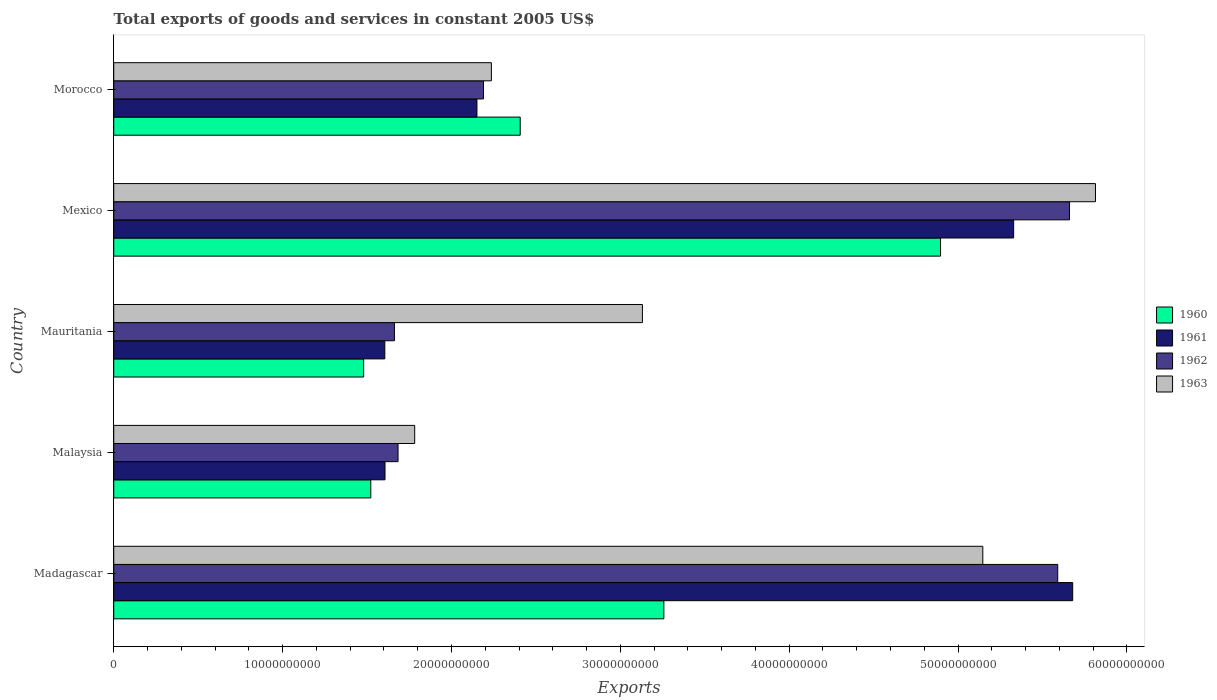How many groups of bars are there?
Provide a short and direct response. 5. Are the number of bars on each tick of the Y-axis equal?
Offer a very short reply. Yes. How many bars are there on the 5th tick from the bottom?
Provide a succinct answer. 4. What is the label of the 3rd group of bars from the top?
Offer a terse response. Mauritania. What is the total exports of goods and services in 1960 in Madagascar?
Your response must be concise. 3.26e+1. Across all countries, what is the maximum total exports of goods and services in 1962?
Your answer should be very brief. 5.66e+1. Across all countries, what is the minimum total exports of goods and services in 1963?
Provide a succinct answer. 1.78e+1. In which country was the total exports of goods and services in 1961 maximum?
Ensure brevity in your answer.  Madagascar. In which country was the total exports of goods and services in 1963 minimum?
Your response must be concise. Malaysia. What is the total total exports of goods and services in 1963 in the graph?
Keep it short and to the point. 1.81e+11. What is the difference between the total exports of goods and services in 1963 in Mexico and that in Morocco?
Give a very brief answer. 3.58e+1. What is the difference between the total exports of goods and services in 1960 in Mauritania and the total exports of goods and services in 1962 in Madagascar?
Give a very brief answer. -4.11e+1. What is the average total exports of goods and services in 1961 per country?
Offer a terse response. 3.27e+1. What is the difference between the total exports of goods and services in 1963 and total exports of goods and services in 1960 in Madagascar?
Offer a very short reply. 1.89e+1. What is the ratio of the total exports of goods and services in 1961 in Malaysia to that in Mexico?
Your response must be concise. 0.3. Is the total exports of goods and services in 1961 in Mexico less than that in Morocco?
Your response must be concise. No. What is the difference between the highest and the second highest total exports of goods and services in 1960?
Provide a succinct answer. 1.64e+1. What is the difference between the highest and the lowest total exports of goods and services in 1960?
Ensure brevity in your answer.  3.42e+1. Is it the case that in every country, the sum of the total exports of goods and services in 1960 and total exports of goods and services in 1962 is greater than the sum of total exports of goods and services in 1963 and total exports of goods and services in 1961?
Provide a short and direct response. No. What does the 1st bar from the top in Morocco represents?
Your response must be concise. 1963. How many countries are there in the graph?
Your answer should be compact. 5. How many legend labels are there?
Keep it short and to the point. 4. How are the legend labels stacked?
Your answer should be very brief. Vertical. What is the title of the graph?
Give a very brief answer. Total exports of goods and services in constant 2005 US$. Does "2007" appear as one of the legend labels in the graph?
Your answer should be compact. No. What is the label or title of the X-axis?
Keep it short and to the point. Exports. What is the Exports in 1960 in Madagascar?
Your answer should be compact. 3.26e+1. What is the Exports in 1961 in Madagascar?
Give a very brief answer. 5.68e+1. What is the Exports in 1962 in Madagascar?
Give a very brief answer. 5.59e+1. What is the Exports of 1963 in Madagascar?
Offer a very short reply. 5.15e+1. What is the Exports of 1960 in Malaysia?
Give a very brief answer. 1.52e+1. What is the Exports in 1961 in Malaysia?
Your answer should be compact. 1.61e+1. What is the Exports of 1962 in Malaysia?
Make the answer very short. 1.68e+1. What is the Exports of 1963 in Malaysia?
Make the answer very short. 1.78e+1. What is the Exports of 1960 in Mauritania?
Keep it short and to the point. 1.48e+1. What is the Exports in 1961 in Mauritania?
Offer a terse response. 1.61e+1. What is the Exports in 1962 in Mauritania?
Your answer should be compact. 1.66e+1. What is the Exports in 1963 in Mauritania?
Offer a very short reply. 3.13e+1. What is the Exports of 1960 in Mexico?
Your response must be concise. 4.90e+1. What is the Exports of 1961 in Mexico?
Ensure brevity in your answer.  5.33e+1. What is the Exports of 1962 in Mexico?
Your response must be concise. 5.66e+1. What is the Exports in 1963 in Mexico?
Keep it short and to the point. 5.81e+1. What is the Exports of 1960 in Morocco?
Provide a succinct answer. 2.41e+1. What is the Exports in 1961 in Morocco?
Your response must be concise. 2.15e+1. What is the Exports in 1962 in Morocco?
Your answer should be compact. 2.19e+1. What is the Exports of 1963 in Morocco?
Keep it short and to the point. 2.24e+1. Across all countries, what is the maximum Exports in 1960?
Your response must be concise. 4.90e+1. Across all countries, what is the maximum Exports of 1961?
Keep it short and to the point. 5.68e+1. Across all countries, what is the maximum Exports of 1962?
Provide a succinct answer. 5.66e+1. Across all countries, what is the maximum Exports in 1963?
Provide a short and direct response. 5.81e+1. Across all countries, what is the minimum Exports of 1960?
Provide a succinct answer. 1.48e+1. Across all countries, what is the minimum Exports of 1961?
Ensure brevity in your answer.  1.61e+1. Across all countries, what is the minimum Exports in 1962?
Your response must be concise. 1.66e+1. Across all countries, what is the minimum Exports in 1963?
Ensure brevity in your answer.  1.78e+1. What is the total Exports in 1960 in the graph?
Ensure brevity in your answer.  1.36e+11. What is the total Exports of 1961 in the graph?
Provide a succinct answer. 1.64e+11. What is the total Exports of 1962 in the graph?
Make the answer very short. 1.68e+11. What is the total Exports in 1963 in the graph?
Offer a very short reply. 1.81e+11. What is the difference between the Exports of 1960 in Madagascar and that in Malaysia?
Provide a succinct answer. 1.74e+1. What is the difference between the Exports in 1961 in Madagascar and that in Malaysia?
Offer a terse response. 4.07e+1. What is the difference between the Exports in 1962 in Madagascar and that in Malaysia?
Keep it short and to the point. 3.91e+1. What is the difference between the Exports of 1963 in Madagascar and that in Malaysia?
Ensure brevity in your answer.  3.36e+1. What is the difference between the Exports in 1960 in Madagascar and that in Mauritania?
Your answer should be compact. 1.78e+1. What is the difference between the Exports in 1961 in Madagascar and that in Mauritania?
Your response must be concise. 4.07e+1. What is the difference between the Exports in 1962 in Madagascar and that in Mauritania?
Your response must be concise. 3.93e+1. What is the difference between the Exports of 1963 in Madagascar and that in Mauritania?
Your response must be concise. 2.02e+1. What is the difference between the Exports of 1960 in Madagascar and that in Mexico?
Give a very brief answer. -1.64e+1. What is the difference between the Exports of 1961 in Madagascar and that in Mexico?
Your response must be concise. 3.50e+09. What is the difference between the Exports in 1962 in Madagascar and that in Mexico?
Provide a short and direct response. -6.99e+08. What is the difference between the Exports of 1963 in Madagascar and that in Mexico?
Keep it short and to the point. -6.67e+09. What is the difference between the Exports of 1960 in Madagascar and that in Morocco?
Provide a short and direct response. 8.51e+09. What is the difference between the Exports in 1961 in Madagascar and that in Morocco?
Make the answer very short. 3.53e+1. What is the difference between the Exports in 1962 in Madagascar and that in Morocco?
Your answer should be very brief. 3.40e+1. What is the difference between the Exports of 1963 in Madagascar and that in Morocco?
Offer a terse response. 2.91e+1. What is the difference between the Exports of 1960 in Malaysia and that in Mauritania?
Give a very brief answer. 4.22e+08. What is the difference between the Exports of 1961 in Malaysia and that in Mauritania?
Provide a short and direct response. 1.20e+07. What is the difference between the Exports in 1962 in Malaysia and that in Mauritania?
Ensure brevity in your answer.  2.15e+08. What is the difference between the Exports of 1963 in Malaysia and that in Mauritania?
Provide a short and direct response. -1.35e+1. What is the difference between the Exports of 1960 in Malaysia and that in Mexico?
Provide a succinct answer. -3.37e+1. What is the difference between the Exports of 1961 in Malaysia and that in Mexico?
Offer a very short reply. -3.72e+1. What is the difference between the Exports of 1962 in Malaysia and that in Mexico?
Your answer should be very brief. -3.98e+1. What is the difference between the Exports in 1963 in Malaysia and that in Mexico?
Make the answer very short. -4.03e+1. What is the difference between the Exports of 1960 in Malaysia and that in Morocco?
Ensure brevity in your answer.  -8.85e+09. What is the difference between the Exports in 1961 in Malaysia and that in Morocco?
Give a very brief answer. -5.44e+09. What is the difference between the Exports in 1962 in Malaysia and that in Morocco?
Ensure brevity in your answer.  -5.06e+09. What is the difference between the Exports of 1963 in Malaysia and that in Morocco?
Your response must be concise. -4.54e+09. What is the difference between the Exports of 1960 in Mauritania and that in Mexico?
Give a very brief answer. -3.42e+1. What is the difference between the Exports of 1961 in Mauritania and that in Mexico?
Give a very brief answer. -3.72e+1. What is the difference between the Exports in 1962 in Mauritania and that in Mexico?
Your response must be concise. -4.00e+1. What is the difference between the Exports in 1963 in Mauritania and that in Mexico?
Provide a short and direct response. -2.68e+1. What is the difference between the Exports in 1960 in Mauritania and that in Morocco?
Give a very brief answer. -9.27e+09. What is the difference between the Exports of 1961 in Mauritania and that in Morocco?
Your answer should be compact. -5.46e+09. What is the difference between the Exports in 1962 in Mauritania and that in Morocco?
Your answer should be very brief. -5.28e+09. What is the difference between the Exports in 1963 in Mauritania and that in Morocco?
Offer a terse response. 8.95e+09. What is the difference between the Exports of 1960 in Mexico and that in Morocco?
Your answer should be very brief. 2.49e+1. What is the difference between the Exports in 1961 in Mexico and that in Morocco?
Offer a very short reply. 3.18e+1. What is the difference between the Exports in 1962 in Mexico and that in Morocco?
Provide a short and direct response. 3.47e+1. What is the difference between the Exports of 1963 in Mexico and that in Morocco?
Give a very brief answer. 3.58e+1. What is the difference between the Exports of 1960 in Madagascar and the Exports of 1961 in Malaysia?
Provide a short and direct response. 1.65e+1. What is the difference between the Exports in 1960 in Madagascar and the Exports in 1962 in Malaysia?
Give a very brief answer. 1.57e+1. What is the difference between the Exports of 1960 in Madagascar and the Exports of 1963 in Malaysia?
Offer a terse response. 1.48e+1. What is the difference between the Exports in 1961 in Madagascar and the Exports in 1962 in Malaysia?
Offer a very short reply. 4.00e+1. What is the difference between the Exports of 1961 in Madagascar and the Exports of 1963 in Malaysia?
Your answer should be very brief. 3.90e+1. What is the difference between the Exports of 1962 in Madagascar and the Exports of 1963 in Malaysia?
Provide a short and direct response. 3.81e+1. What is the difference between the Exports of 1960 in Madagascar and the Exports of 1961 in Mauritania?
Keep it short and to the point. 1.65e+1. What is the difference between the Exports of 1960 in Madagascar and the Exports of 1962 in Mauritania?
Provide a succinct answer. 1.60e+1. What is the difference between the Exports in 1960 in Madagascar and the Exports in 1963 in Mauritania?
Make the answer very short. 1.27e+09. What is the difference between the Exports in 1961 in Madagascar and the Exports in 1962 in Mauritania?
Ensure brevity in your answer.  4.02e+1. What is the difference between the Exports in 1961 in Madagascar and the Exports in 1963 in Mauritania?
Make the answer very short. 2.55e+1. What is the difference between the Exports in 1962 in Madagascar and the Exports in 1963 in Mauritania?
Keep it short and to the point. 2.46e+1. What is the difference between the Exports in 1960 in Madagascar and the Exports in 1961 in Mexico?
Your response must be concise. -2.07e+1. What is the difference between the Exports of 1960 in Madagascar and the Exports of 1962 in Mexico?
Your answer should be very brief. -2.40e+1. What is the difference between the Exports in 1960 in Madagascar and the Exports in 1963 in Mexico?
Provide a succinct answer. -2.56e+1. What is the difference between the Exports of 1961 in Madagascar and the Exports of 1962 in Mexico?
Your answer should be very brief. 1.89e+08. What is the difference between the Exports of 1961 in Madagascar and the Exports of 1963 in Mexico?
Give a very brief answer. -1.35e+09. What is the difference between the Exports in 1962 in Madagascar and the Exports in 1963 in Mexico?
Your response must be concise. -2.24e+09. What is the difference between the Exports in 1960 in Madagascar and the Exports in 1961 in Morocco?
Your answer should be compact. 1.11e+1. What is the difference between the Exports of 1960 in Madagascar and the Exports of 1962 in Morocco?
Your response must be concise. 1.07e+1. What is the difference between the Exports of 1960 in Madagascar and the Exports of 1963 in Morocco?
Make the answer very short. 1.02e+1. What is the difference between the Exports in 1961 in Madagascar and the Exports in 1962 in Morocco?
Your answer should be very brief. 3.49e+1. What is the difference between the Exports in 1961 in Madagascar and the Exports in 1963 in Morocco?
Give a very brief answer. 3.44e+1. What is the difference between the Exports in 1962 in Madagascar and the Exports in 1963 in Morocco?
Offer a terse response. 3.35e+1. What is the difference between the Exports in 1960 in Malaysia and the Exports in 1961 in Mauritania?
Your answer should be very brief. -8.31e+08. What is the difference between the Exports of 1960 in Malaysia and the Exports of 1962 in Mauritania?
Provide a succinct answer. -1.40e+09. What is the difference between the Exports of 1960 in Malaysia and the Exports of 1963 in Mauritania?
Ensure brevity in your answer.  -1.61e+1. What is the difference between the Exports in 1961 in Malaysia and the Exports in 1962 in Mauritania?
Make the answer very short. -5.57e+08. What is the difference between the Exports in 1961 in Malaysia and the Exports in 1963 in Mauritania?
Offer a very short reply. -1.52e+1. What is the difference between the Exports of 1962 in Malaysia and the Exports of 1963 in Mauritania?
Ensure brevity in your answer.  -1.45e+1. What is the difference between the Exports in 1960 in Malaysia and the Exports in 1961 in Mexico?
Provide a succinct answer. -3.81e+1. What is the difference between the Exports in 1960 in Malaysia and the Exports in 1962 in Mexico?
Provide a short and direct response. -4.14e+1. What is the difference between the Exports in 1960 in Malaysia and the Exports in 1963 in Mexico?
Offer a very short reply. -4.29e+1. What is the difference between the Exports of 1961 in Malaysia and the Exports of 1962 in Mexico?
Provide a succinct answer. -4.05e+1. What is the difference between the Exports of 1961 in Malaysia and the Exports of 1963 in Mexico?
Provide a succinct answer. -4.21e+1. What is the difference between the Exports of 1962 in Malaysia and the Exports of 1963 in Mexico?
Ensure brevity in your answer.  -4.13e+1. What is the difference between the Exports in 1960 in Malaysia and the Exports in 1961 in Morocco?
Provide a succinct answer. -6.29e+09. What is the difference between the Exports in 1960 in Malaysia and the Exports in 1962 in Morocco?
Give a very brief answer. -6.68e+09. What is the difference between the Exports of 1960 in Malaysia and the Exports of 1963 in Morocco?
Keep it short and to the point. -7.14e+09. What is the difference between the Exports in 1961 in Malaysia and the Exports in 1962 in Morocco?
Offer a very short reply. -5.83e+09. What is the difference between the Exports in 1961 in Malaysia and the Exports in 1963 in Morocco?
Give a very brief answer. -6.30e+09. What is the difference between the Exports of 1962 in Malaysia and the Exports of 1963 in Morocco?
Provide a succinct answer. -5.53e+09. What is the difference between the Exports in 1960 in Mauritania and the Exports in 1961 in Mexico?
Give a very brief answer. -3.85e+1. What is the difference between the Exports in 1960 in Mauritania and the Exports in 1962 in Mexico?
Provide a succinct answer. -4.18e+1. What is the difference between the Exports in 1960 in Mauritania and the Exports in 1963 in Mexico?
Your answer should be compact. -4.33e+1. What is the difference between the Exports in 1961 in Mauritania and the Exports in 1962 in Mexico?
Your answer should be very brief. -4.05e+1. What is the difference between the Exports in 1961 in Mauritania and the Exports in 1963 in Mexico?
Offer a very short reply. -4.21e+1. What is the difference between the Exports in 1962 in Mauritania and the Exports in 1963 in Mexico?
Your answer should be compact. -4.15e+1. What is the difference between the Exports of 1960 in Mauritania and the Exports of 1961 in Morocco?
Your answer should be compact. -6.71e+09. What is the difference between the Exports of 1960 in Mauritania and the Exports of 1962 in Morocco?
Provide a short and direct response. -7.10e+09. What is the difference between the Exports in 1960 in Mauritania and the Exports in 1963 in Morocco?
Offer a very short reply. -7.56e+09. What is the difference between the Exports of 1961 in Mauritania and the Exports of 1962 in Morocco?
Keep it short and to the point. -5.85e+09. What is the difference between the Exports in 1961 in Mauritania and the Exports in 1963 in Morocco?
Keep it short and to the point. -6.31e+09. What is the difference between the Exports in 1962 in Mauritania and the Exports in 1963 in Morocco?
Provide a succinct answer. -5.74e+09. What is the difference between the Exports in 1960 in Mexico and the Exports in 1961 in Morocco?
Offer a terse response. 2.75e+1. What is the difference between the Exports in 1960 in Mexico and the Exports in 1962 in Morocco?
Give a very brief answer. 2.71e+1. What is the difference between the Exports of 1960 in Mexico and the Exports of 1963 in Morocco?
Give a very brief answer. 2.66e+1. What is the difference between the Exports of 1961 in Mexico and the Exports of 1962 in Morocco?
Your response must be concise. 3.14e+1. What is the difference between the Exports of 1961 in Mexico and the Exports of 1963 in Morocco?
Your response must be concise. 3.09e+1. What is the difference between the Exports in 1962 in Mexico and the Exports in 1963 in Morocco?
Give a very brief answer. 3.42e+1. What is the average Exports in 1960 per country?
Offer a terse response. 2.71e+1. What is the average Exports in 1961 per country?
Your response must be concise. 3.27e+1. What is the average Exports in 1962 per country?
Your answer should be very brief. 3.36e+1. What is the average Exports of 1963 per country?
Provide a short and direct response. 3.62e+1. What is the difference between the Exports of 1960 and Exports of 1961 in Madagascar?
Your answer should be very brief. -2.42e+1. What is the difference between the Exports in 1960 and Exports in 1962 in Madagascar?
Make the answer very short. -2.33e+1. What is the difference between the Exports in 1960 and Exports in 1963 in Madagascar?
Your response must be concise. -1.89e+1. What is the difference between the Exports in 1961 and Exports in 1962 in Madagascar?
Your answer should be compact. 8.87e+08. What is the difference between the Exports of 1961 and Exports of 1963 in Madagascar?
Ensure brevity in your answer.  5.32e+09. What is the difference between the Exports in 1962 and Exports in 1963 in Madagascar?
Provide a short and direct response. 4.44e+09. What is the difference between the Exports of 1960 and Exports of 1961 in Malaysia?
Provide a short and direct response. -8.42e+08. What is the difference between the Exports in 1960 and Exports in 1962 in Malaysia?
Make the answer very short. -1.61e+09. What is the difference between the Exports of 1960 and Exports of 1963 in Malaysia?
Give a very brief answer. -2.60e+09. What is the difference between the Exports in 1961 and Exports in 1962 in Malaysia?
Make the answer very short. -7.72e+08. What is the difference between the Exports in 1961 and Exports in 1963 in Malaysia?
Your response must be concise. -1.76e+09. What is the difference between the Exports of 1962 and Exports of 1963 in Malaysia?
Offer a terse response. -9.85e+08. What is the difference between the Exports in 1960 and Exports in 1961 in Mauritania?
Your response must be concise. -1.25e+09. What is the difference between the Exports in 1960 and Exports in 1962 in Mauritania?
Offer a very short reply. -1.82e+09. What is the difference between the Exports in 1960 and Exports in 1963 in Mauritania?
Give a very brief answer. -1.65e+1. What is the difference between the Exports of 1961 and Exports of 1962 in Mauritania?
Your answer should be compact. -5.69e+08. What is the difference between the Exports in 1961 and Exports in 1963 in Mauritania?
Offer a terse response. -1.53e+1. What is the difference between the Exports of 1962 and Exports of 1963 in Mauritania?
Offer a very short reply. -1.47e+1. What is the difference between the Exports in 1960 and Exports in 1961 in Mexico?
Your answer should be very brief. -4.33e+09. What is the difference between the Exports of 1960 and Exports of 1962 in Mexico?
Provide a short and direct response. -7.64e+09. What is the difference between the Exports in 1960 and Exports in 1963 in Mexico?
Offer a terse response. -9.17e+09. What is the difference between the Exports of 1961 and Exports of 1962 in Mexico?
Offer a terse response. -3.31e+09. What is the difference between the Exports of 1961 and Exports of 1963 in Mexico?
Offer a terse response. -4.84e+09. What is the difference between the Exports of 1962 and Exports of 1963 in Mexico?
Offer a terse response. -1.54e+09. What is the difference between the Exports in 1960 and Exports in 1961 in Morocco?
Provide a short and direct response. 2.56e+09. What is the difference between the Exports in 1960 and Exports in 1962 in Morocco?
Provide a short and direct response. 2.17e+09. What is the difference between the Exports of 1960 and Exports of 1963 in Morocco?
Offer a very short reply. 1.71e+09. What is the difference between the Exports in 1961 and Exports in 1962 in Morocco?
Make the answer very short. -3.89e+08. What is the difference between the Exports of 1961 and Exports of 1963 in Morocco?
Ensure brevity in your answer.  -8.54e+08. What is the difference between the Exports of 1962 and Exports of 1963 in Morocco?
Keep it short and to the point. -4.65e+08. What is the ratio of the Exports of 1960 in Madagascar to that in Malaysia?
Your answer should be compact. 2.14. What is the ratio of the Exports of 1961 in Madagascar to that in Malaysia?
Your answer should be very brief. 3.54. What is the ratio of the Exports in 1962 in Madagascar to that in Malaysia?
Offer a terse response. 3.32. What is the ratio of the Exports of 1963 in Madagascar to that in Malaysia?
Offer a very short reply. 2.89. What is the ratio of the Exports of 1960 in Madagascar to that in Mauritania?
Offer a very short reply. 2.2. What is the ratio of the Exports of 1961 in Madagascar to that in Mauritania?
Your answer should be very brief. 3.54. What is the ratio of the Exports in 1962 in Madagascar to that in Mauritania?
Provide a short and direct response. 3.36. What is the ratio of the Exports of 1963 in Madagascar to that in Mauritania?
Give a very brief answer. 1.64. What is the ratio of the Exports in 1960 in Madagascar to that in Mexico?
Offer a very short reply. 0.67. What is the ratio of the Exports of 1961 in Madagascar to that in Mexico?
Make the answer very short. 1.07. What is the ratio of the Exports of 1962 in Madagascar to that in Mexico?
Your answer should be very brief. 0.99. What is the ratio of the Exports of 1963 in Madagascar to that in Mexico?
Your answer should be compact. 0.89. What is the ratio of the Exports in 1960 in Madagascar to that in Morocco?
Keep it short and to the point. 1.35. What is the ratio of the Exports of 1961 in Madagascar to that in Morocco?
Provide a succinct answer. 2.64. What is the ratio of the Exports in 1962 in Madagascar to that in Morocco?
Your response must be concise. 2.55. What is the ratio of the Exports of 1963 in Madagascar to that in Morocco?
Offer a very short reply. 2.3. What is the ratio of the Exports in 1960 in Malaysia to that in Mauritania?
Ensure brevity in your answer.  1.03. What is the ratio of the Exports in 1961 in Malaysia to that in Mauritania?
Offer a terse response. 1. What is the ratio of the Exports of 1962 in Malaysia to that in Mauritania?
Offer a terse response. 1.01. What is the ratio of the Exports in 1963 in Malaysia to that in Mauritania?
Your response must be concise. 0.57. What is the ratio of the Exports of 1960 in Malaysia to that in Mexico?
Your answer should be very brief. 0.31. What is the ratio of the Exports of 1961 in Malaysia to that in Mexico?
Give a very brief answer. 0.3. What is the ratio of the Exports in 1962 in Malaysia to that in Mexico?
Provide a succinct answer. 0.3. What is the ratio of the Exports of 1963 in Malaysia to that in Mexico?
Ensure brevity in your answer.  0.31. What is the ratio of the Exports of 1960 in Malaysia to that in Morocco?
Make the answer very short. 0.63. What is the ratio of the Exports in 1961 in Malaysia to that in Morocco?
Your answer should be compact. 0.75. What is the ratio of the Exports of 1962 in Malaysia to that in Morocco?
Offer a terse response. 0.77. What is the ratio of the Exports of 1963 in Malaysia to that in Morocco?
Ensure brevity in your answer.  0.8. What is the ratio of the Exports of 1960 in Mauritania to that in Mexico?
Ensure brevity in your answer.  0.3. What is the ratio of the Exports of 1961 in Mauritania to that in Mexico?
Make the answer very short. 0.3. What is the ratio of the Exports in 1962 in Mauritania to that in Mexico?
Your answer should be very brief. 0.29. What is the ratio of the Exports of 1963 in Mauritania to that in Mexico?
Offer a very short reply. 0.54. What is the ratio of the Exports in 1960 in Mauritania to that in Morocco?
Offer a terse response. 0.61. What is the ratio of the Exports of 1961 in Mauritania to that in Morocco?
Give a very brief answer. 0.75. What is the ratio of the Exports of 1962 in Mauritania to that in Morocco?
Your response must be concise. 0.76. What is the ratio of the Exports in 1960 in Mexico to that in Morocco?
Offer a terse response. 2.03. What is the ratio of the Exports in 1961 in Mexico to that in Morocco?
Provide a succinct answer. 2.48. What is the ratio of the Exports in 1962 in Mexico to that in Morocco?
Your answer should be compact. 2.58. What is the ratio of the Exports of 1963 in Mexico to that in Morocco?
Offer a very short reply. 2.6. What is the difference between the highest and the second highest Exports of 1960?
Your answer should be very brief. 1.64e+1. What is the difference between the highest and the second highest Exports in 1961?
Make the answer very short. 3.50e+09. What is the difference between the highest and the second highest Exports of 1962?
Offer a terse response. 6.99e+08. What is the difference between the highest and the second highest Exports of 1963?
Provide a succinct answer. 6.67e+09. What is the difference between the highest and the lowest Exports of 1960?
Keep it short and to the point. 3.42e+1. What is the difference between the highest and the lowest Exports of 1961?
Provide a short and direct response. 4.07e+1. What is the difference between the highest and the lowest Exports in 1962?
Offer a very short reply. 4.00e+1. What is the difference between the highest and the lowest Exports in 1963?
Ensure brevity in your answer.  4.03e+1. 